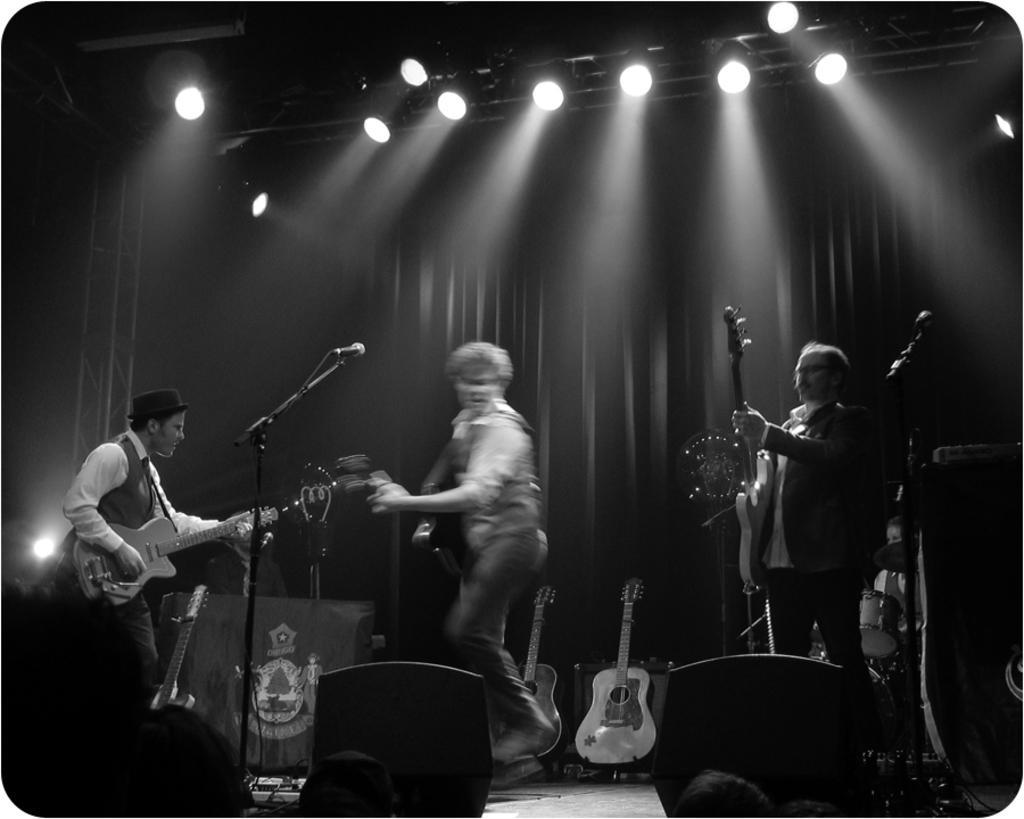In one or two sentences, can you explain what this image depicts? In this image I can see few men are standing and holding guitars I can also see mice and few more guitars in the background. 